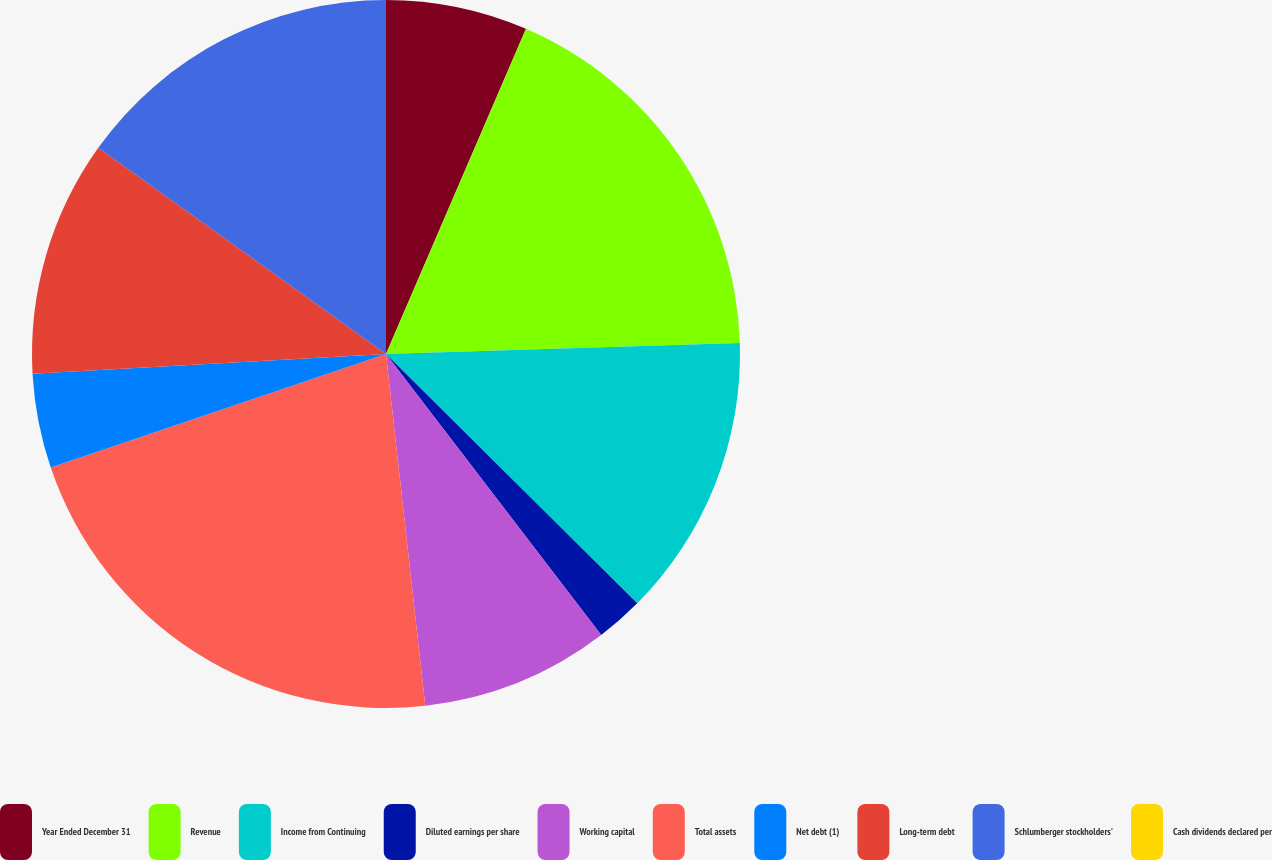<chart> <loc_0><loc_0><loc_500><loc_500><pie_chart><fcel>Year Ended December 31<fcel>Revenue<fcel>Income from Continuing<fcel>Diluted earnings per share<fcel>Working capital<fcel>Total assets<fcel>Net debt (1)<fcel>Long-term debt<fcel>Schlumberger stockholders'<fcel>Cash dividends declared per<nl><fcel>6.47%<fcel>18.03%<fcel>12.94%<fcel>2.16%<fcel>8.63%<fcel>21.57%<fcel>4.31%<fcel>10.79%<fcel>15.1%<fcel>0.0%<nl></chart> 